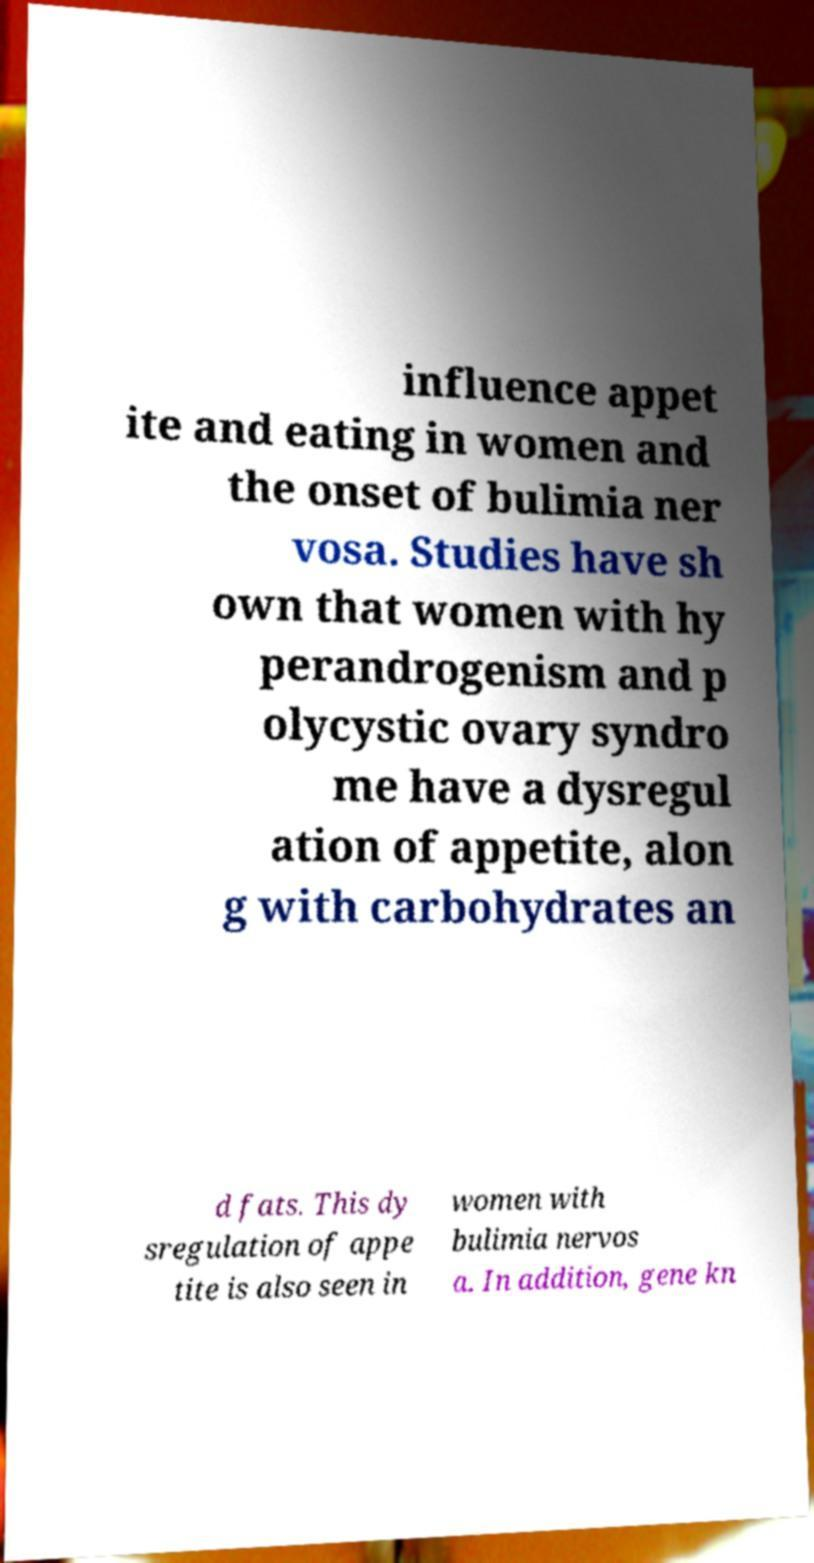Can you accurately transcribe the text from the provided image for me? influence appet ite and eating in women and the onset of bulimia ner vosa. Studies have sh own that women with hy perandrogenism and p olycystic ovary syndro me have a dysregul ation of appetite, alon g with carbohydrates an d fats. This dy sregulation of appe tite is also seen in women with bulimia nervos a. In addition, gene kn 